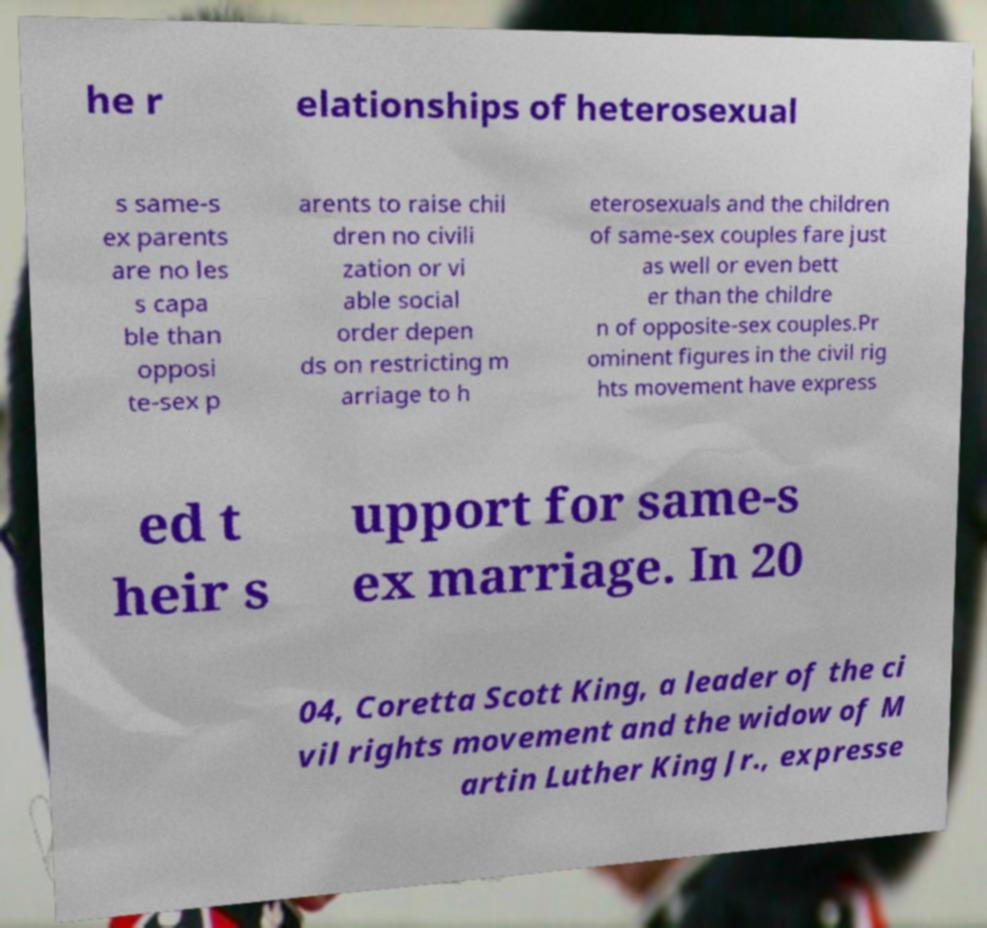Can you accurately transcribe the text from the provided image for me? he r elationships of heterosexual s same-s ex parents are no les s capa ble than opposi te-sex p arents to raise chil dren no civili zation or vi able social order depen ds on restricting m arriage to h eterosexuals and the children of same-sex couples fare just as well or even bett er than the childre n of opposite-sex couples.Pr ominent figures in the civil rig hts movement have express ed t heir s upport for same-s ex marriage. In 20 04, Coretta Scott King, a leader of the ci vil rights movement and the widow of M artin Luther King Jr., expresse 